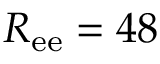<formula> <loc_0><loc_0><loc_500><loc_500>R _ { e e } = 4 8</formula> 